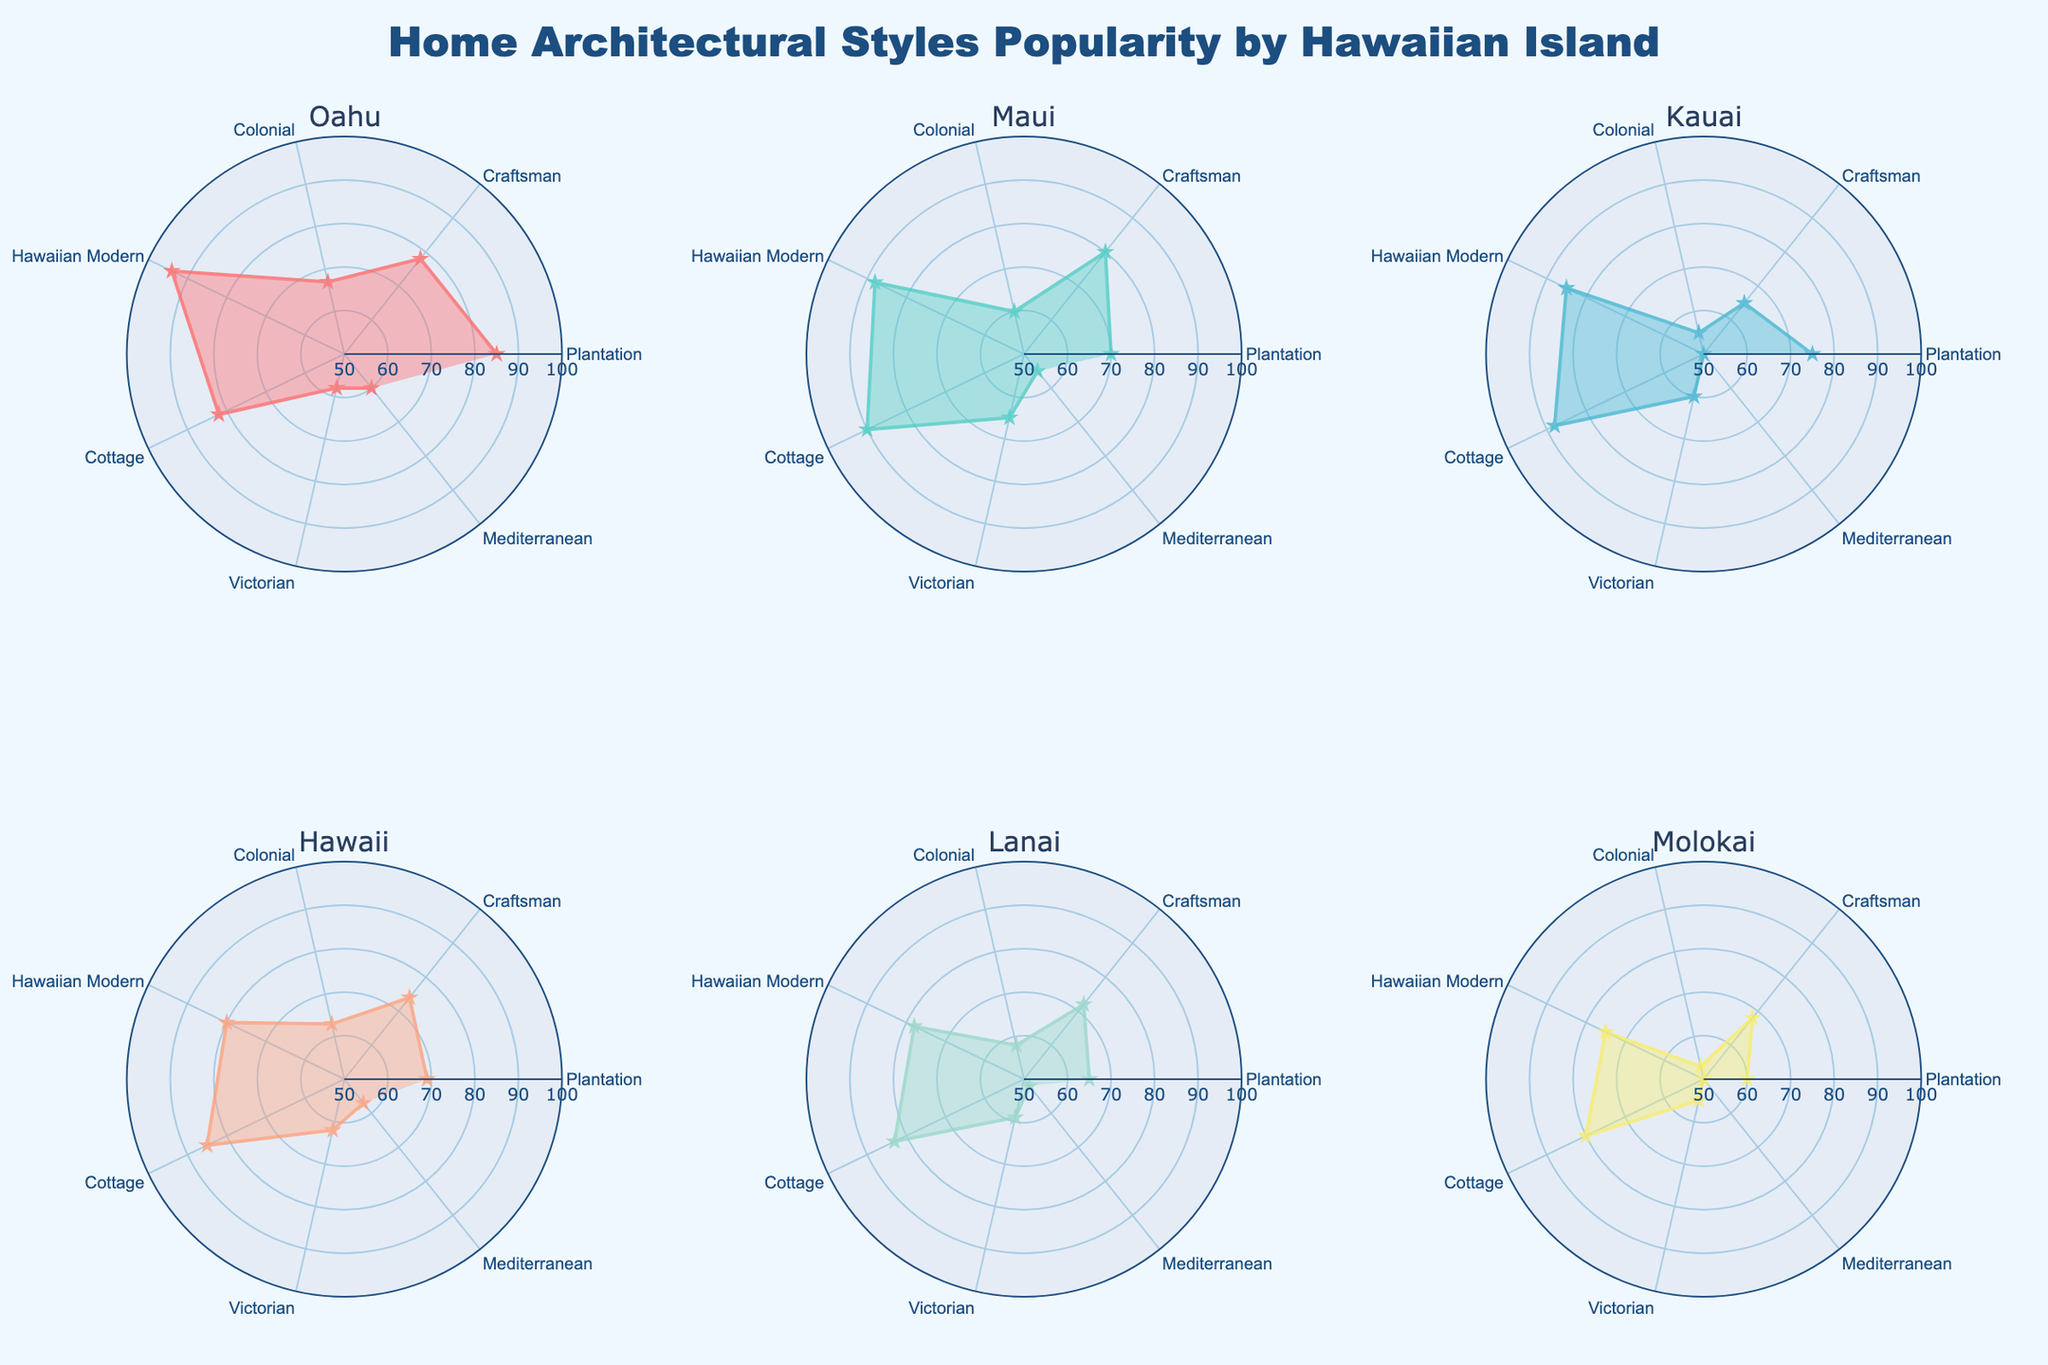Which island has the highest preference for the 'Hawaiian Modern' architectural style? By examining the radar charts, 'Hawaiian Modern' style is represented as a point on the chart for each island. The island with the highest value for this style is Oahu with a value of 94.
Answer: Oahu What is the average popularity score of the 'Cottage' style across all the islands? The 'Cottage' style scores for each island are [82, 90, 88, 85, 83, 80]. Summing these values gives 508. The average is then calculated by dividing this sum by the number of islands (6): 508 / 6 = 84.67.
Answer: 84.67 Which island has the least variation in popularity scores across different architectural styles? To determine the least variation, we need to visually assess standard deviations from each island’s radar chart. Based on visual inspection, Lanai appears to have the least variation among its values from 65 to 83.
Answer: Lanai For the 'Colonial' style, which two islands have the smallest difference in their popularity scores? The 'Colonial' style scores for the islands are [67, 60, 55, 63, 58, 53]. By comparing these scores, the smallest difference is between Lanai (58) and Maui (60) with a difference of 2.
Answer: Lanai and Maui What’s the total popularity score sum for the 'Victorian' style across all the islands? Adding the 'Victorian' style scores for all the islands gives: 58 (Oahu) + 65 (Maui) + 60 (Kauai) + 62 (Hawaii) + 59 (Lanai) + 55 (Molokai). This equals 359.
Answer: 359 How does the preference for the ‘Craftsman’ style on Oahu compare with Kauai? By comparing the 'Craftsman' style values from the radar charts, Oahu has a value of 78 and Kauai has a value of 65. The difference is 78 - 65 = 13.
Answer: 13 more for Oahu Which style has the most consistent popularity across all the islands? Visually examining the distances from the center for each style, the 'Cottage' style shows values ranging between 80 and 90, making it the most consistent across all islands.
Answer: Cottage Is the 'Mediterranean' style more popular on Hawaii or Lanai? From the radar charts, the values for 'Mediterranean' style are 57 for Hawaii and 52 for Lanai. Thus, it is more popular on Hawaii.
Answer: Hawaii 